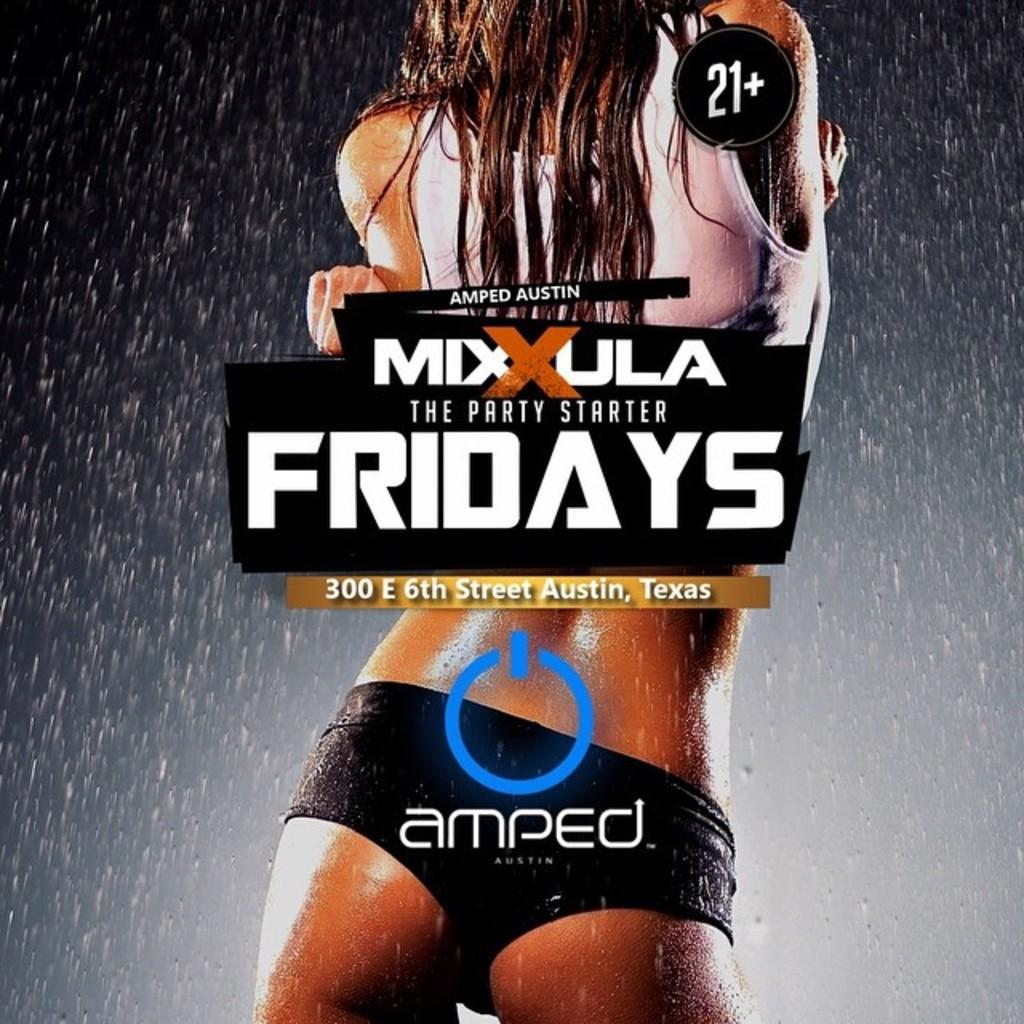What type of visual representation is shown in the image? The image is a poster. Who or what is featured on the poster? There is a person depicted on the poster. What natural element is also shown on the poster? There is water depicted on the poster. Are there any words or phrases on the poster? Yes, there is text on the poster. How many pigs are visible on the poster? There are no pigs depicted on the poster; it features a person and water. What type of scale is used to measure the water on the poster? There is no scale present on the poster, and the amount of water is not quantified. 